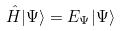Convert formula to latex. <formula><loc_0><loc_0><loc_500><loc_500>\hat { H } | \Psi \rangle = E _ { \Psi } | \Psi \rangle</formula> 